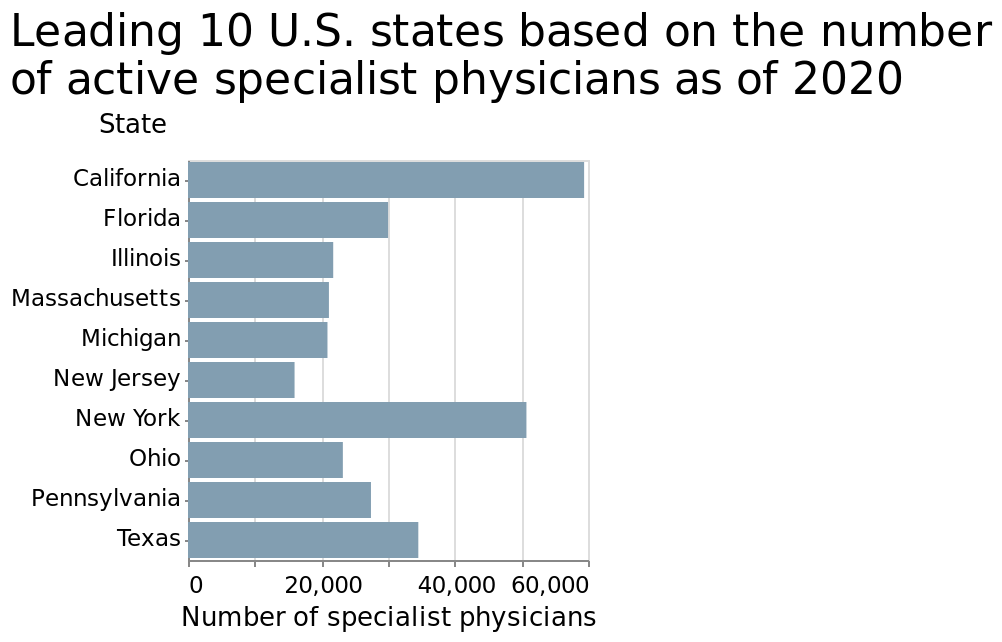<image>
What aspect does the y-axis represent in the chart?  The y-axis represents the states in the chart. What year is the data from?  The data is from the year 2020. 